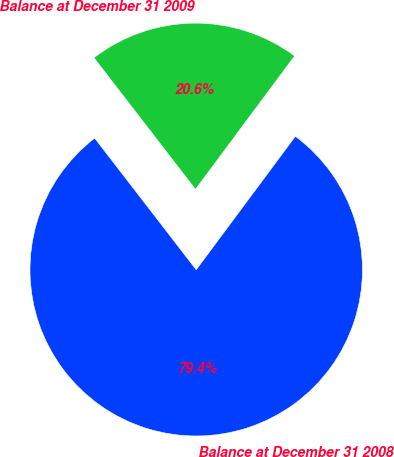Convert chart. <chart><loc_0><loc_0><loc_500><loc_500><pie_chart><fcel>Balance at December 31 2008<fcel>Balance at December 31 2009<nl><fcel>79.37%<fcel>20.63%<nl></chart> 